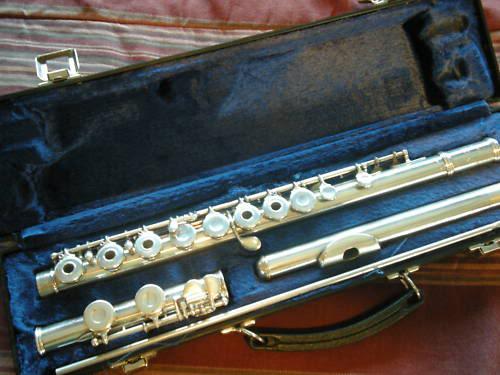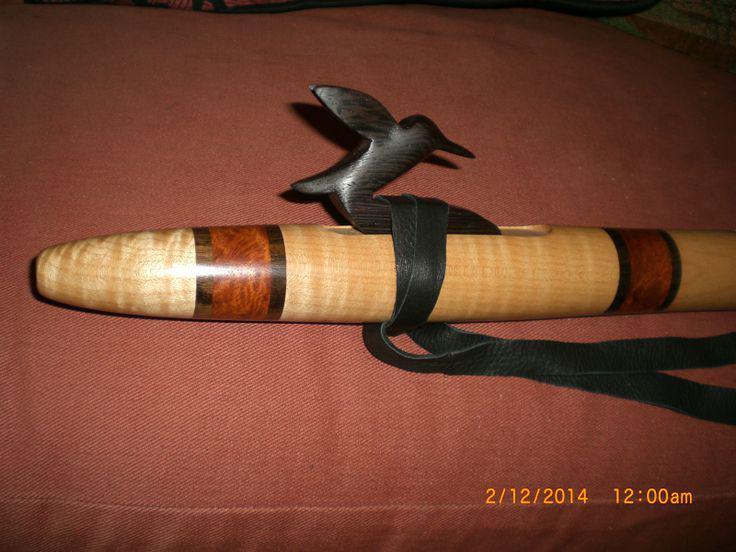The first image is the image on the left, the second image is the image on the right. Given the left and right images, does the statement "IN at least one image there is a flute end sitting on a squarded rock." hold true? Answer yes or no. No. 